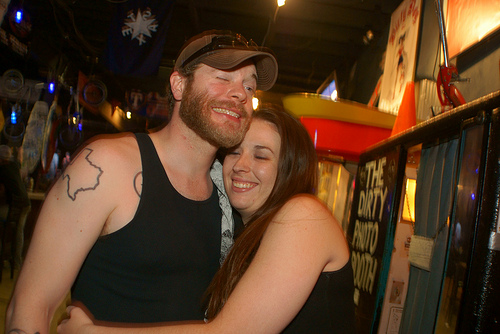<image>
Is the man on the woman? Yes. Looking at the image, I can see the man is positioned on top of the woman, with the woman providing support. Where is the men in relation to the women? Is it on the women? No. The men is not positioned on the women. They may be near each other, but the men is not supported by or resting on top of the women. Where is the hat in relation to the woman? Is it on the woman? No. The hat is not positioned on the woman. They may be near each other, but the hat is not supported by or resting on top of the woman. 